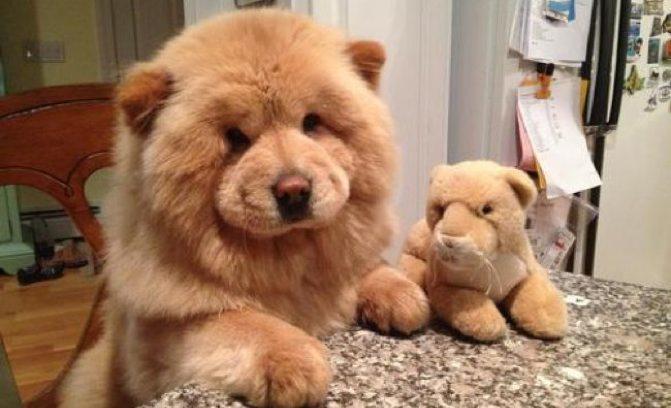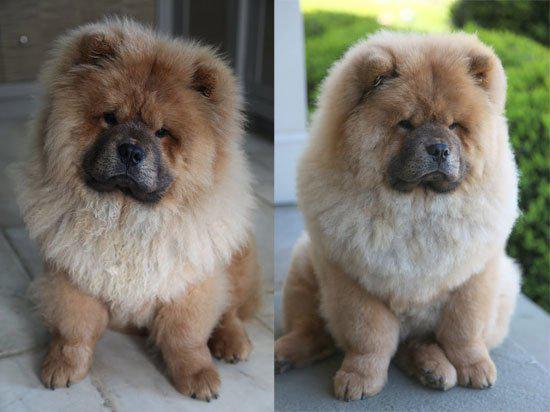The first image is the image on the left, the second image is the image on the right. For the images shown, is this caption "A chow dog with its blue tongue showing is standing on all fours with its body in profile." true? Answer yes or no. No. The first image is the image on the left, the second image is the image on the right. Given the left and right images, does the statement "There is exactly one dog in the right image." hold true? Answer yes or no. No. 